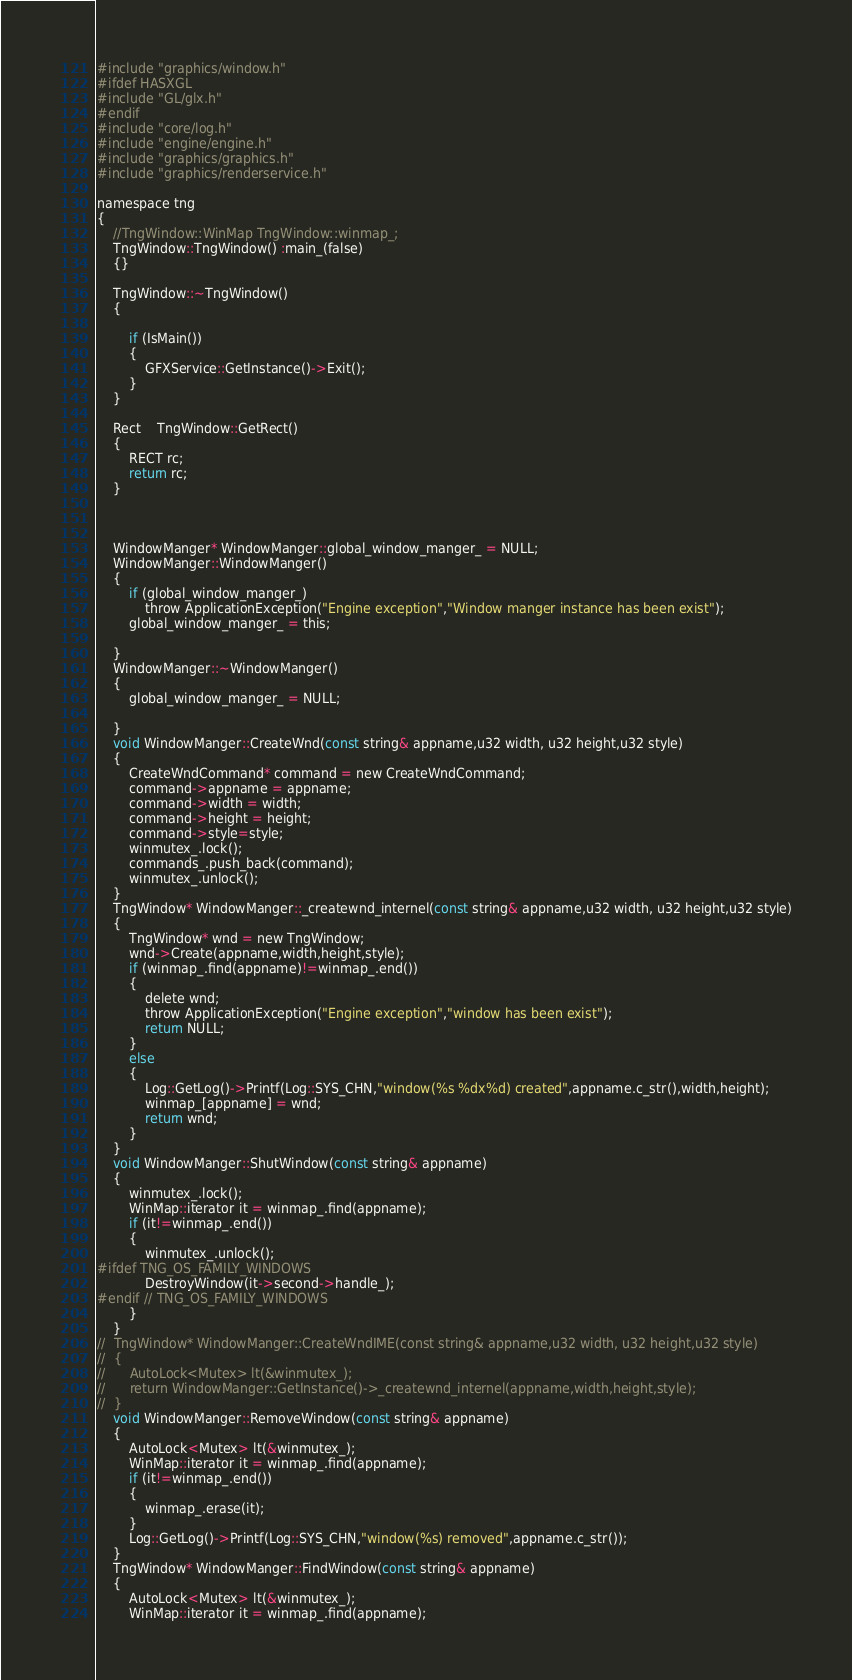<code> <loc_0><loc_0><loc_500><loc_500><_ObjectiveC_>
#include "graphics/window.h"
#ifdef HASXGL
#include "GL/glx.h"
#endif
#include "core/log.h"
#include "engine/engine.h"
#include "graphics/graphics.h"
#include "graphics/renderservice.h"

namespace tng
{
	//TngWindow::WinMap TngWindow::winmap_;
	TngWindow::TngWindow() :main_(false)
	{}

	TngWindow::~TngWindow()
	{

		if (IsMain())
		{
			GFXService::GetInstance()->Exit();
		}
	}

	Rect	TngWindow::GetRect()
	{
		RECT rc;
		return rc;
	}
	


	WindowManger* WindowManger::global_window_manger_ = NULL;
	WindowManger::WindowManger()
	{
		if (global_window_manger_)
			throw ApplicationException("Engine exception","Window manger instance has been exist");
		global_window_manger_ = this;

	}
	WindowManger::~WindowManger()
	{
		global_window_manger_ = NULL;

	}
	void WindowManger::CreateWnd(const string& appname,u32 width, u32 height,u32 style)
	{
		CreateWndCommand* command = new CreateWndCommand;
		command->appname = appname;
		command->width = width;
		command->height = height;
		command->style=style;
		winmutex_.lock();
		commands_.push_back(command);
		winmutex_.unlock();
	}
	TngWindow* WindowManger::_createwnd_internel(const string& appname,u32 width, u32 height,u32 style)
	{
		TngWindow* wnd = new TngWindow;
		wnd->Create(appname,width,height,style);
		if (winmap_.find(appname)!=winmap_.end())
		{
			delete wnd;
			throw ApplicationException("Engine exception","window has been exist");
			return NULL;
		}
		else
		{
			Log::GetLog()->Printf(Log::SYS_CHN,"window(%s %dx%d) created",appname.c_str(),width,height);
			winmap_[appname] = wnd;
			return wnd;
		}
	}
	void WindowManger::ShutWindow(const string& appname)
	{
		winmutex_.lock();
		WinMap::iterator it = winmap_.find(appname);
		if (it!=winmap_.end())
		{
			winmutex_.unlock();
#ifdef TNG_OS_FAMILY_WINDOWS
			DestroyWindow(it->second->handle_);
#endif // TNG_OS_FAMILY_WINDOWS
		}
	}
// 	TngWindow* WindowManger::CreateWndIME(const string& appname,u32 width, u32 height,u32 style)
// 	{
// 		AutoLock<Mutex> lt(&winmutex_);
// 		return WindowManger::GetInstance()->_createwnd_internel(appname,width,height,style);
// 	}
	void WindowManger::RemoveWindow(const string& appname)
	{
		AutoLock<Mutex> lt(&winmutex_);
		WinMap::iterator it = winmap_.find(appname);
		if (it!=winmap_.end())
		{
			winmap_.erase(it);
		}
		Log::GetLog()->Printf(Log::SYS_CHN,"window(%s) removed",appname.c_str());
	}
	TngWindow* WindowManger::FindWindow(const string& appname)
	{
		AutoLock<Mutex> lt(&winmutex_);
		WinMap::iterator it = winmap_.find(appname);</code> 